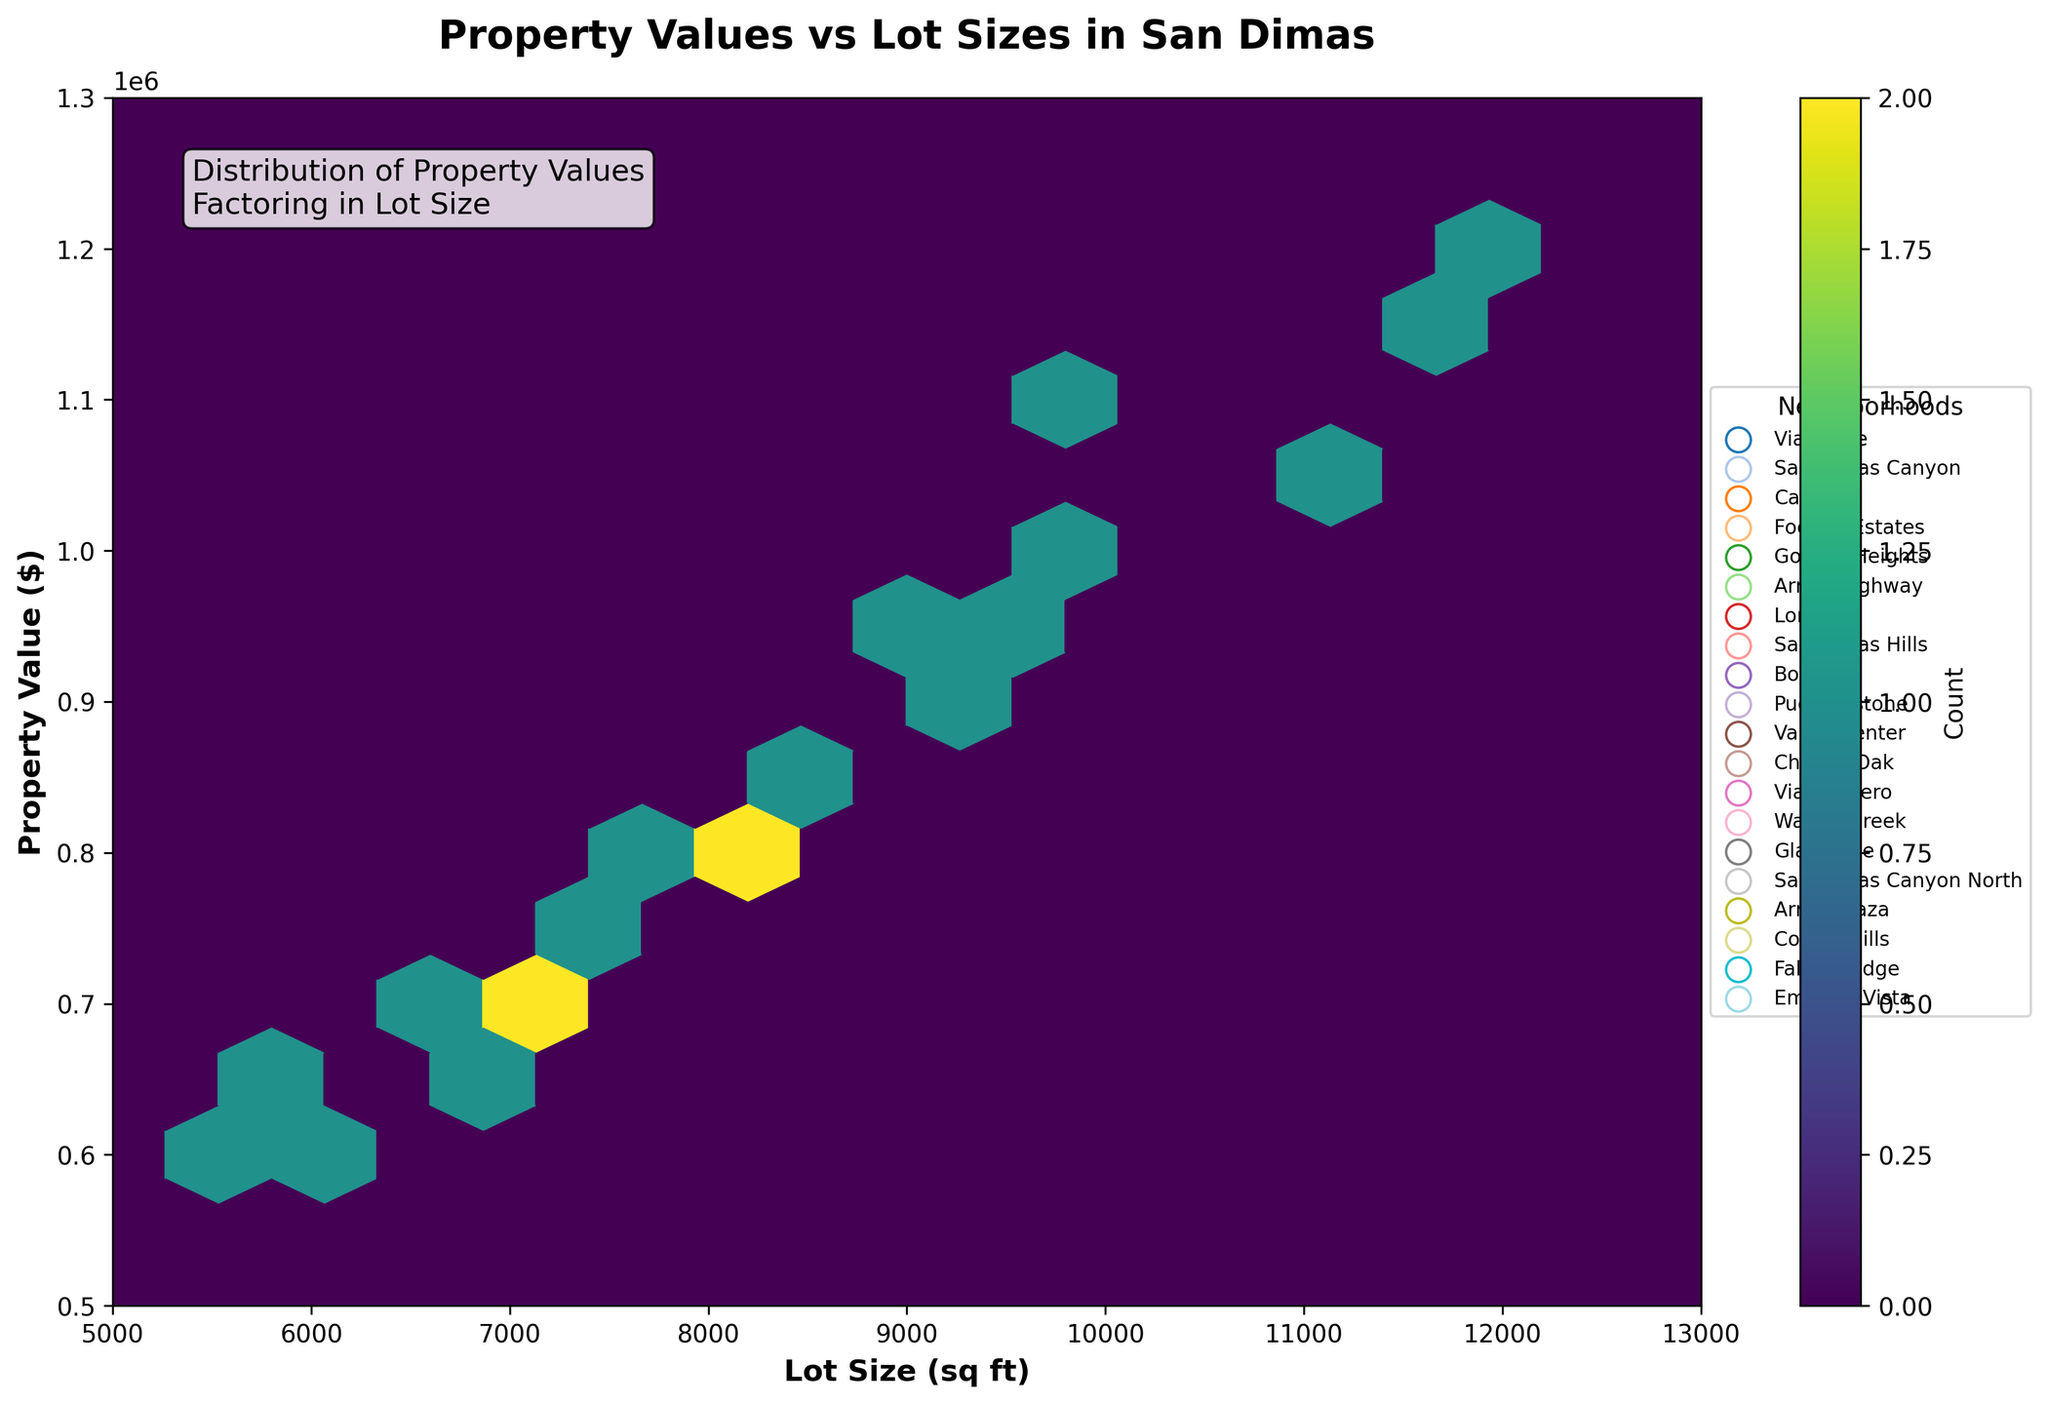How many data points are shown in the hexbin plot? By examining the color bar and the individual hexagons, one can estimate the total number of data points shown on the plot. Each hexagon's color intensity indicates the number of data points it represents.
Answer: 20 What is the title of the plot? The title is directly stated at the top of the plot.
Answer: Property Values vs Lot Sizes in San Dimas What are the labels for the x and y axes? The labels are directly stated along the axes. The x-axis label is "Lot Size (sq ft)" and the y-axis label is "Property Value ($)".
Answer: Lot Size (sq ft) and Property Value ($) Which neighborhood has the highest property value? The legend indicates the different neighborhoods, and by looking at the y-axis values and the hexagons corresponding to each neighborhood, one can identify the highest property value.
Answer: San Dimas Hills Is there a correlation between lot size and property value? The hexbin plot shows the density of points representing property values and lot sizes. A general upward trend indicates a positive correlation.
Answer: Yes Which hexagonal bin appears the most densely populated? The color bar indicates the density of data points within each hexagonal bin. The bin with the highest intensity color represents the highest density.
Answer: The one around 11000 sq ft lot size and $1100000 property value What is the range of years in which the properties were built? While the years are not directly plotted, the scatter of the points and the labeled neighborhoods can be used to estimate the range based on known construction timelines in San Dimas. Properties range from the year 1965 to 2010.
Answer: 1965 to 2010 Are there more high-value properties (above $900,000) on larger lots (above 9000 sq ft)? By examining the concentration of hexagons placed in the upper right quadrant (above $900,000 and above 9000 sq ft lot size), one can see if more data points are clustered in that region.
Answer: Yes Which neighborhoods have the least variation in terms of property values and lot sizes? By observing the spread of hexagons for each neighborhood's color in the plot, one can identify neighborhoods with a smaller spread, indicating less variation.
Answer: Arrow Highway and Arrow Plaza 